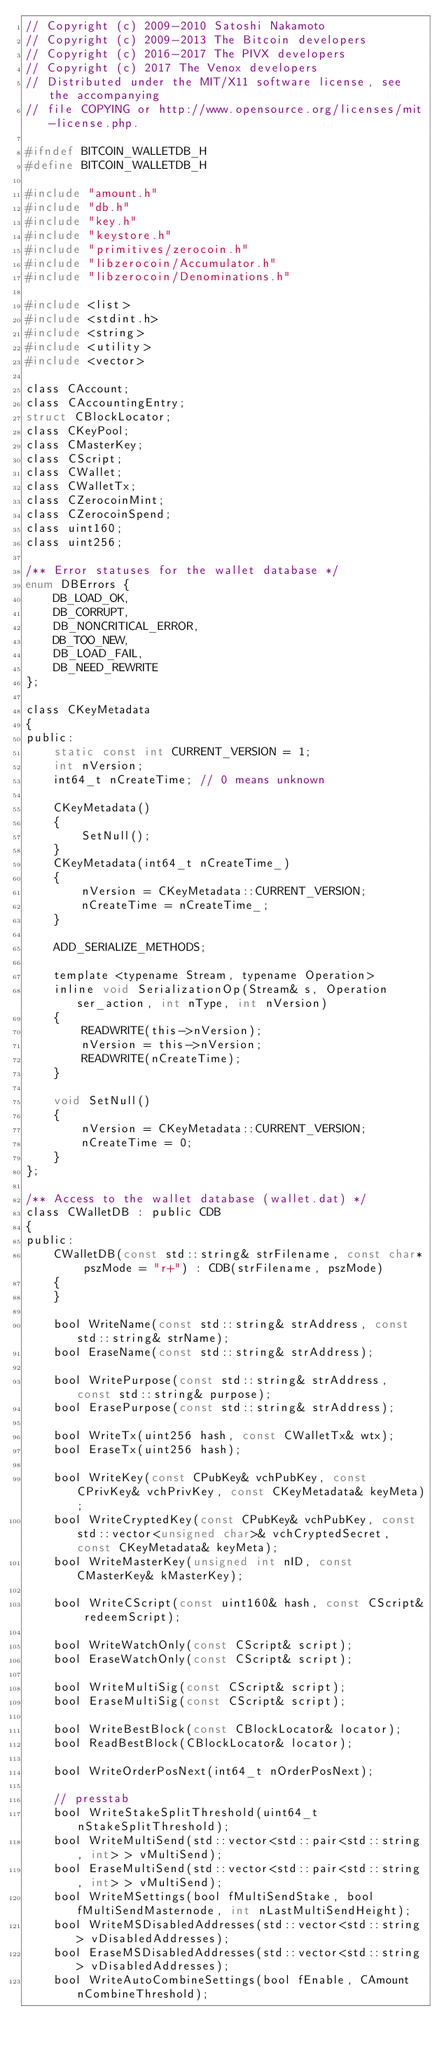<code> <loc_0><loc_0><loc_500><loc_500><_C_>// Copyright (c) 2009-2010 Satoshi Nakamoto
// Copyright (c) 2009-2013 The Bitcoin developers
// Copyright (c) 2016-2017 The PIVX developers
// Copyright (c) 2017 The Venox developers
// Distributed under the MIT/X11 software license, see the accompanying
// file COPYING or http://www.opensource.org/licenses/mit-license.php.

#ifndef BITCOIN_WALLETDB_H
#define BITCOIN_WALLETDB_H

#include "amount.h"
#include "db.h"
#include "key.h"
#include "keystore.h"
#include "primitives/zerocoin.h"
#include "libzerocoin/Accumulator.h"
#include "libzerocoin/Denominations.h"

#include <list>
#include <stdint.h>
#include <string>
#include <utility>
#include <vector>

class CAccount;
class CAccountingEntry;
struct CBlockLocator;
class CKeyPool;
class CMasterKey;
class CScript;
class CWallet;
class CWalletTx;
class CZerocoinMint;
class CZerocoinSpend;
class uint160;
class uint256;

/** Error statuses for the wallet database */
enum DBErrors {
    DB_LOAD_OK,
    DB_CORRUPT,
    DB_NONCRITICAL_ERROR,
    DB_TOO_NEW,
    DB_LOAD_FAIL,
    DB_NEED_REWRITE
};

class CKeyMetadata
{
public:
    static const int CURRENT_VERSION = 1;
    int nVersion;
    int64_t nCreateTime; // 0 means unknown

    CKeyMetadata()
    {
        SetNull();
    }
    CKeyMetadata(int64_t nCreateTime_)
    {
        nVersion = CKeyMetadata::CURRENT_VERSION;
        nCreateTime = nCreateTime_;
    }

    ADD_SERIALIZE_METHODS;

    template <typename Stream, typename Operation>
    inline void SerializationOp(Stream& s, Operation ser_action, int nType, int nVersion)
    {
        READWRITE(this->nVersion);
        nVersion = this->nVersion;
        READWRITE(nCreateTime);
    }

    void SetNull()
    {
        nVersion = CKeyMetadata::CURRENT_VERSION;
        nCreateTime = 0;
    }
};

/** Access to the wallet database (wallet.dat) */
class CWalletDB : public CDB
{
public:
    CWalletDB(const std::string& strFilename, const char* pszMode = "r+") : CDB(strFilename, pszMode)
    {
    }

    bool WriteName(const std::string& strAddress, const std::string& strName);
    bool EraseName(const std::string& strAddress);

    bool WritePurpose(const std::string& strAddress, const std::string& purpose);
    bool ErasePurpose(const std::string& strAddress);

    bool WriteTx(uint256 hash, const CWalletTx& wtx);
    bool EraseTx(uint256 hash);

    bool WriteKey(const CPubKey& vchPubKey, const CPrivKey& vchPrivKey, const CKeyMetadata& keyMeta);
    bool WriteCryptedKey(const CPubKey& vchPubKey, const std::vector<unsigned char>& vchCryptedSecret, const CKeyMetadata& keyMeta);
    bool WriteMasterKey(unsigned int nID, const CMasterKey& kMasterKey);

    bool WriteCScript(const uint160& hash, const CScript& redeemScript);

    bool WriteWatchOnly(const CScript& script);
    bool EraseWatchOnly(const CScript& script);

    bool WriteMultiSig(const CScript& script);
    bool EraseMultiSig(const CScript& script);

    bool WriteBestBlock(const CBlockLocator& locator);
    bool ReadBestBlock(CBlockLocator& locator);

    bool WriteOrderPosNext(int64_t nOrderPosNext);

    // presstab
    bool WriteStakeSplitThreshold(uint64_t nStakeSplitThreshold);
    bool WriteMultiSend(std::vector<std::pair<std::string, int> > vMultiSend);
    bool EraseMultiSend(std::vector<std::pair<std::string, int> > vMultiSend);
    bool WriteMSettings(bool fMultiSendStake, bool fMultiSendMasternode, int nLastMultiSendHeight);
    bool WriteMSDisabledAddresses(std::vector<std::string> vDisabledAddresses);
    bool EraseMSDisabledAddresses(std::vector<std::string> vDisabledAddresses);
    bool WriteAutoCombineSettings(bool fEnable, CAmount nCombineThreshold);
</code> 